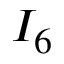Convert formula to latex. <formula><loc_0><loc_0><loc_500><loc_500>I _ { 6 }</formula> 